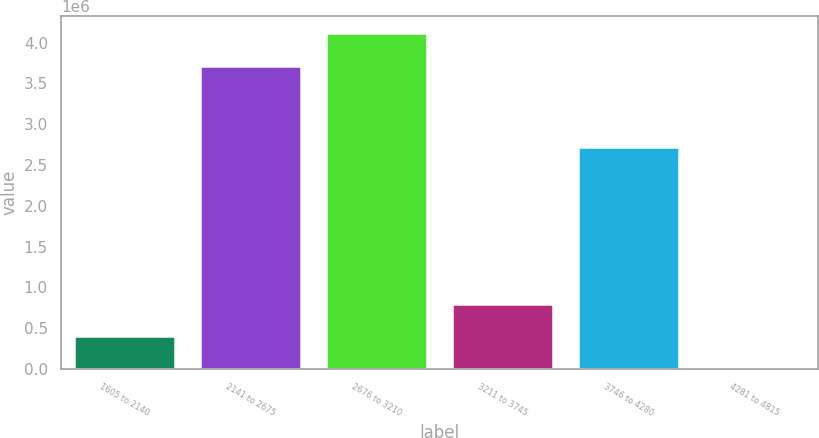<chart> <loc_0><loc_0><loc_500><loc_500><bar_chart><fcel>1605 to 2140<fcel>2141 to 2675<fcel>2676 to 3210<fcel>3211 to 3745<fcel>3746 to 4280<fcel>4281 to 4815<nl><fcel>403130<fcel>3.7193e+06<fcel>4.11813e+06<fcel>801953<fcel>2.71831e+06<fcel>4308<nl></chart> 